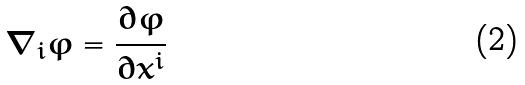<formula> <loc_0><loc_0><loc_500><loc_500>\nabla _ { i } \varphi = \frac { \partial \varphi } { \partial x ^ { i } }</formula> 